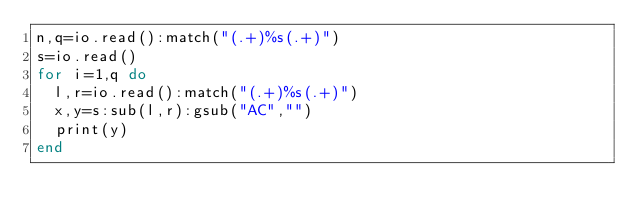<code> <loc_0><loc_0><loc_500><loc_500><_Lua_>n,q=io.read():match("(.+)%s(.+)")
s=io.read()
for i=1,q do
  l,r=io.read():match("(.+)%s(.+)")
  x,y=s:sub(l,r):gsub("AC","")
  print(y)
end</code> 